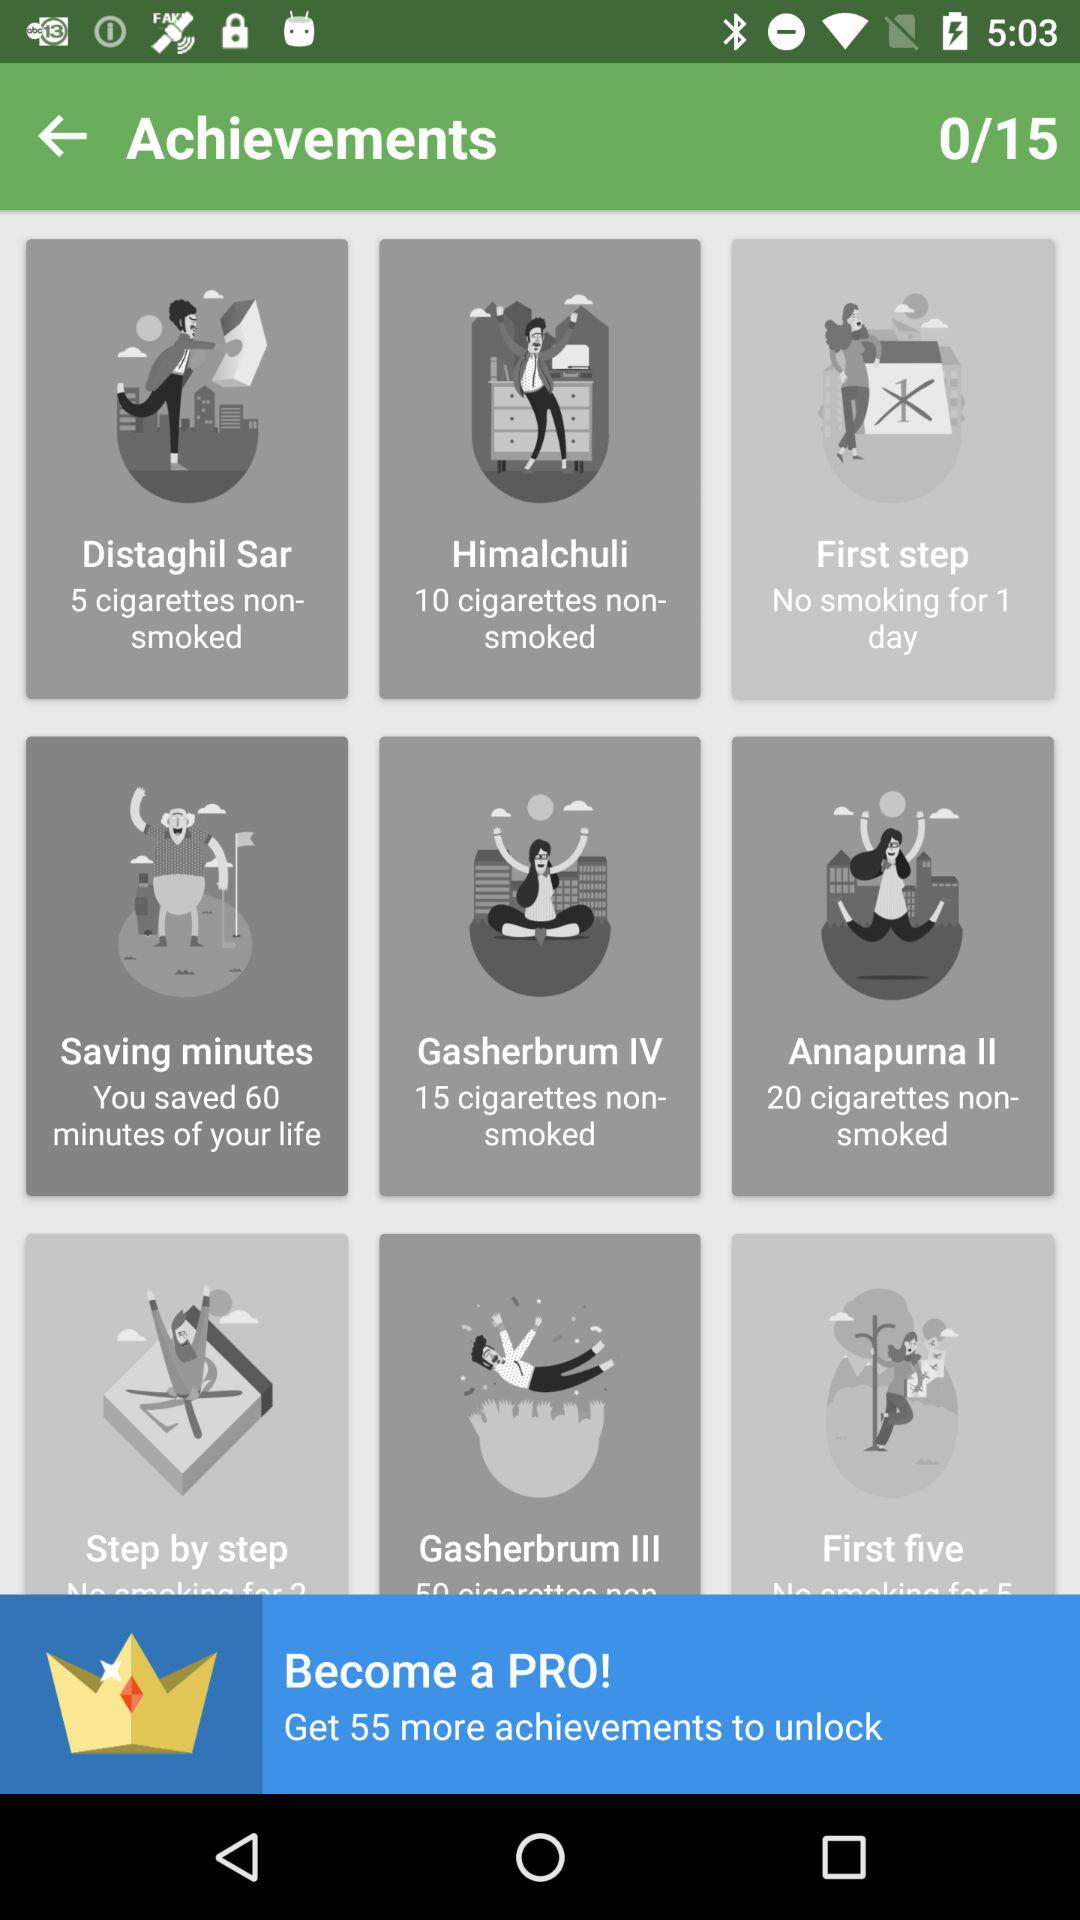What is the total number of achievements? The total number of achievements is 15. 